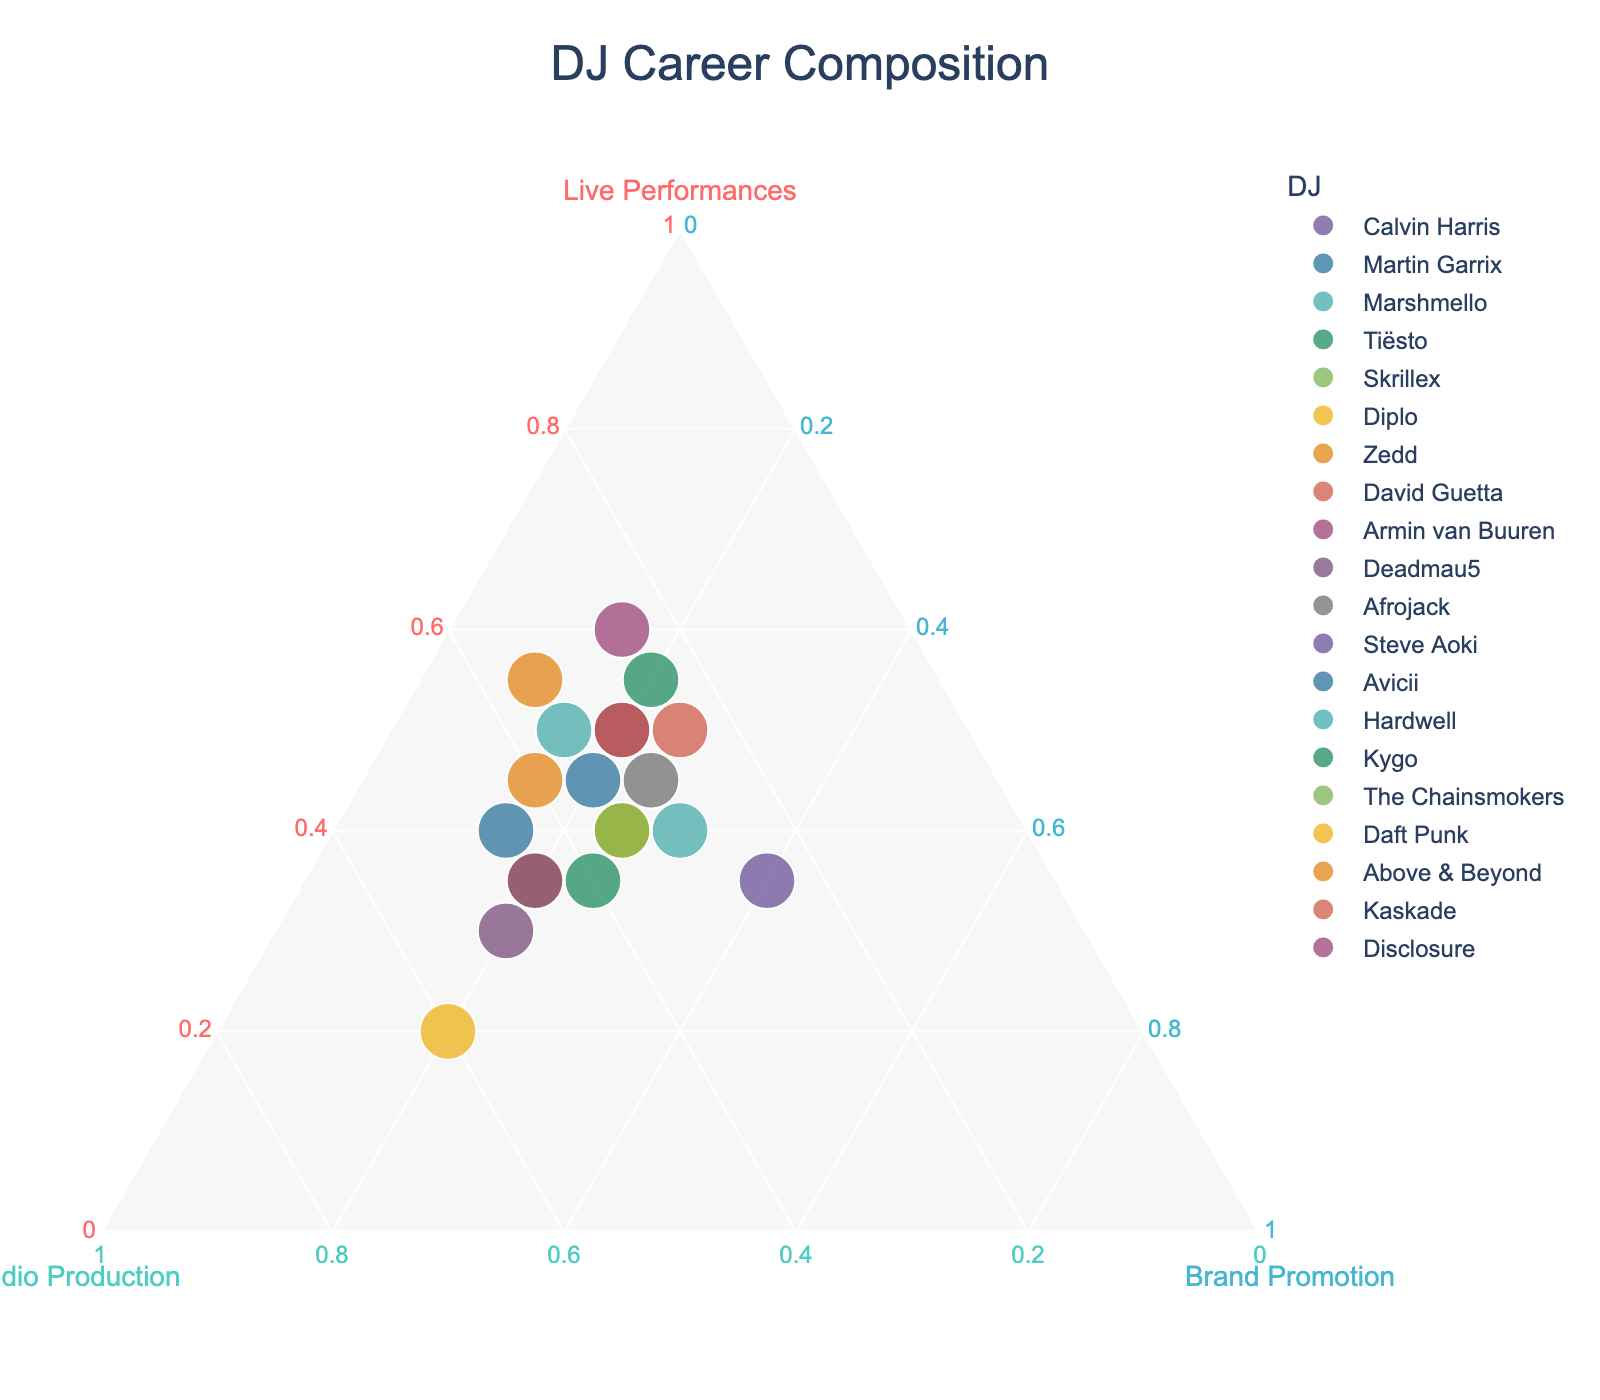Which DJ places the highest emphasis on live performances? The DJ with the highest percentage for live performances will have their point closest to the Live Performances axis. From the figure, Armin van Buuren has the highest percentage in live performances.
Answer: Armin van Buuren Which DJ focuses the least on brand promotion? The DJ with the smallest percentage in brand promotion will have their point farthest from the Brand Promotion axis. From the figure, Above & Beyond has the lowest percentage of brand promotion.
Answer: Above & Beyond What is the composition of Skrillex's career? Look at Skrillex’s position in the ternary plot. Extract the percentages for live performances, studio production, and brand promotion. Skrillex has a distribution of 35% live performances, 45% studio production, and 20% brand promotion.
Answer: 35% live performances, 45% studio production, 20% brand promotion Who has a balanced career between studio production and brand promotion? A balanced career would appear closer to the line between the Studio Production and Brand Promotion axes. Steve Aoki has an almost equal percentage between the two categories: 25% studio production and 40% brand promotion.
Answer: Steve Aoki Which DJ places the least emphasis on live performances? The DJ with the lowest percentage in live performances will be farthest from the Live Performances axis. Daft Punk has the lowest percentage in live performances.
Answer: Daft Punk How many DJs allocate exactly 30% to studio production? Count the number of points exactly on the line for 30% studio production. From the plot, Calvin Harris, Marshmello, and David Guetta each allocate 30% to studio production.
Answer: 3 What is unique about Daft Punk's career composition compared to others? Identify the distinct characteristics of Daft Punk’s position in the plot. Daft Punk is unique as they have the highest allocation to studio production at 60%, which is higher than any other DJ.
Answer: Highest studio production at 60% Which DJ has a career composition closest to the average of the group's proportions? Calculate the mean percentages for live performances, studio production, and brand promotion. The average across the DJs is approximately 43% live performances, 34% studio production, and 23% brand promotion. The Chainsmokers' composition (40%, 35%, 25%) is closest to this average.
Answer: The Chainsmokers How does Kygo’s career composition compare to Zedd’s? Compare the percentages for live performances, studio production, and brand promotion for Kygo and Zedd. Kygo and Zedd both focus heavily on studio production and live performances, but Kygo has more brand promotion than Zedd. Kygo: 35% live performances, 40% studio production, 25% brand promotion. Zedd: 45% live performances, 40% studio production, 15% brand promotion.
Answer: Kygo has more brand promotion and less live performance 